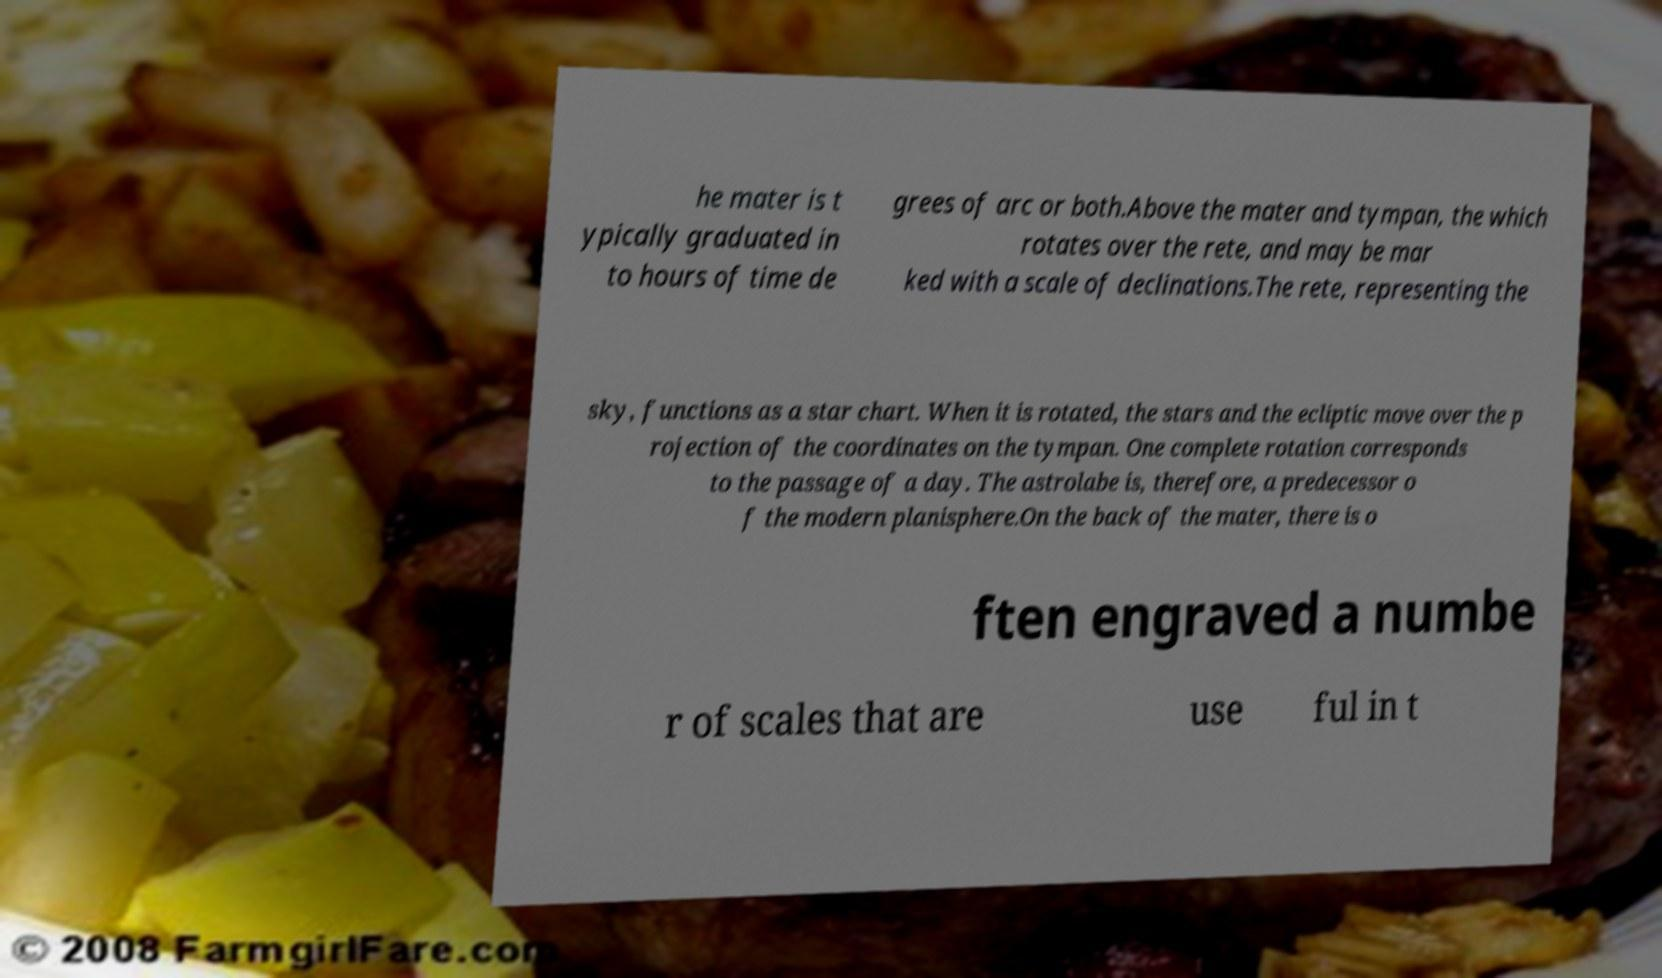I need the written content from this picture converted into text. Can you do that? he mater is t ypically graduated in to hours of time de grees of arc or both.Above the mater and tympan, the which rotates over the rete, and may be mar ked with a scale of declinations.The rete, representing the sky, functions as a star chart. When it is rotated, the stars and the ecliptic move over the p rojection of the coordinates on the tympan. One complete rotation corresponds to the passage of a day. The astrolabe is, therefore, a predecessor o f the modern planisphere.On the back of the mater, there is o ften engraved a numbe r of scales that are use ful in t 